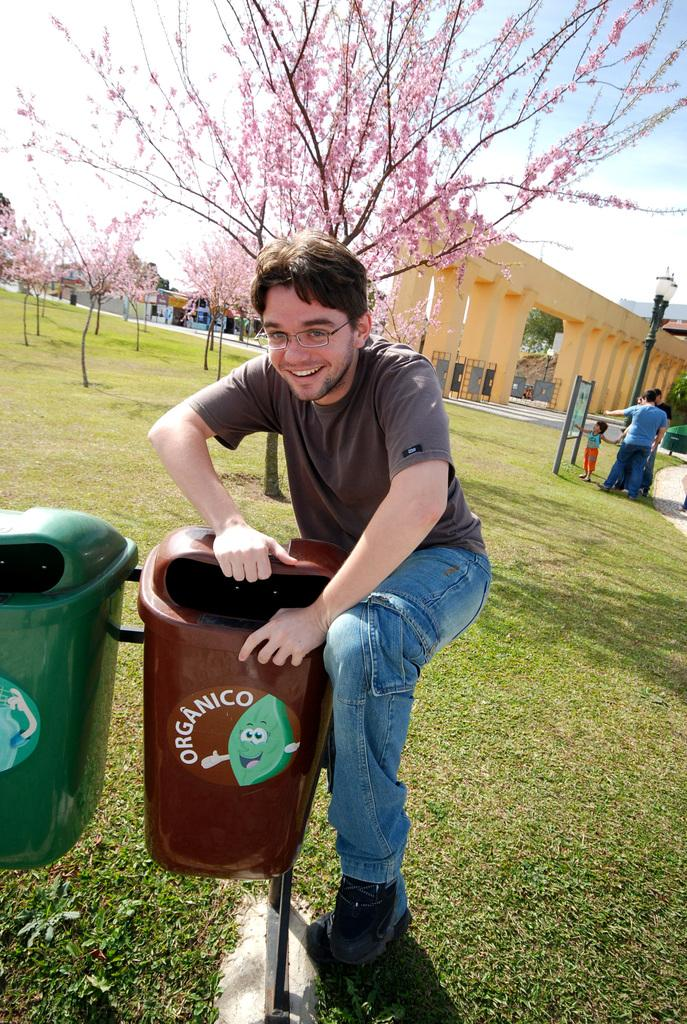Provide a one-sentence caption for the provided image. A man posing with a trash can that says "Organico" on it. 